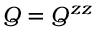Convert formula to latex. <formula><loc_0><loc_0><loc_500><loc_500>Q = Q ^ { z z }</formula> 